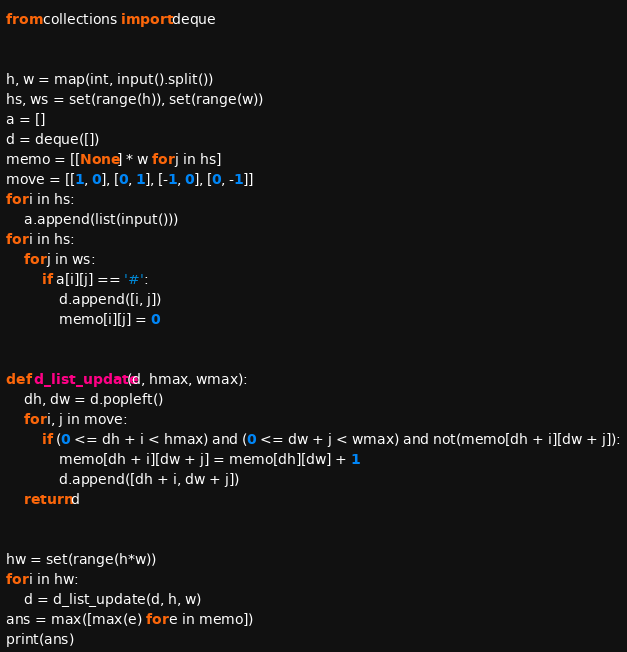Convert code to text. <code><loc_0><loc_0><loc_500><loc_500><_Python_>from collections import deque


h, w = map(int, input().split())
hs, ws = set(range(h)), set(range(w))
a = []
d = deque([])
memo = [[None] * w for j in hs]
move = [[1, 0], [0, 1], [-1, 0], [0, -1]]
for i in hs:
    a.append(list(input()))
for i in hs:
    for j in ws:
        if a[i][j] == '#':
            d.append([i, j])
            memo[i][j] = 0


def d_list_update(d, hmax, wmax):
    dh, dw = d.popleft()
    for i, j in move:
        if (0 <= dh + i < hmax) and (0 <= dw + j < wmax) and not(memo[dh + i][dw + j]):
            memo[dh + i][dw + j] = memo[dh][dw] + 1
            d.append([dh + i, dw + j])
    return d


hw = set(range(h*w))
for i in hw:
    d = d_list_update(d, h, w)
ans = max([max(e) for e in memo])
print(ans)</code> 